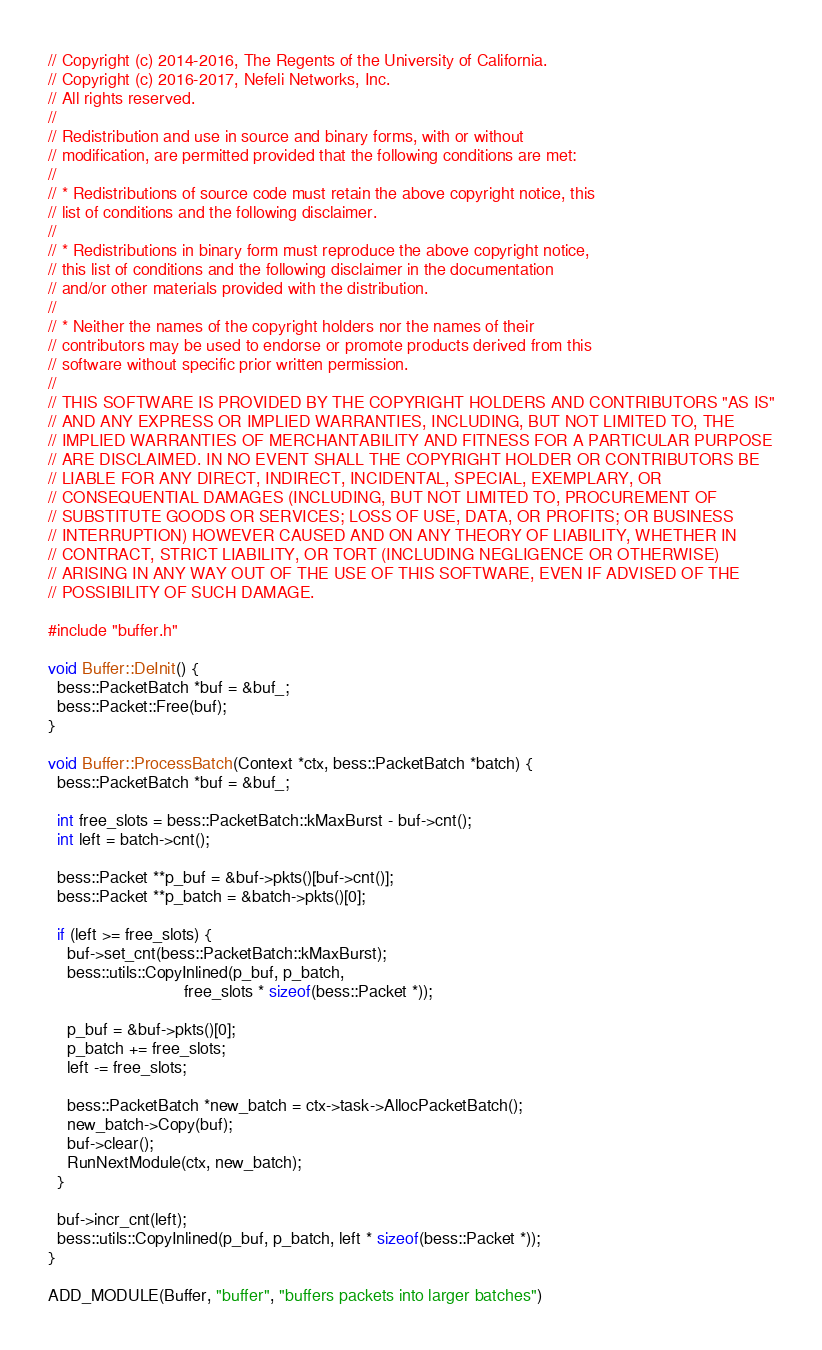Convert code to text. <code><loc_0><loc_0><loc_500><loc_500><_C++_>// Copyright (c) 2014-2016, The Regents of the University of California.
// Copyright (c) 2016-2017, Nefeli Networks, Inc.
// All rights reserved.
//
// Redistribution and use in source and binary forms, with or without
// modification, are permitted provided that the following conditions are met:
//
// * Redistributions of source code must retain the above copyright notice, this
// list of conditions and the following disclaimer.
//
// * Redistributions in binary form must reproduce the above copyright notice,
// this list of conditions and the following disclaimer in the documentation
// and/or other materials provided with the distribution.
//
// * Neither the names of the copyright holders nor the names of their
// contributors may be used to endorse or promote products derived from this
// software without specific prior written permission.
//
// THIS SOFTWARE IS PROVIDED BY THE COPYRIGHT HOLDERS AND CONTRIBUTORS "AS IS"
// AND ANY EXPRESS OR IMPLIED WARRANTIES, INCLUDING, BUT NOT LIMITED TO, THE
// IMPLIED WARRANTIES OF MERCHANTABILITY AND FITNESS FOR A PARTICULAR PURPOSE
// ARE DISCLAIMED. IN NO EVENT SHALL THE COPYRIGHT HOLDER OR CONTRIBUTORS BE
// LIABLE FOR ANY DIRECT, INDIRECT, INCIDENTAL, SPECIAL, EXEMPLARY, OR
// CONSEQUENTIAL DAMAGES (INCLUDING, BUT NOT LIMITED TO, PROCUREMENT OF
// SUBSTITUTE GOODS OR SERVICES; LOSS OF USE, DATA, OR PROFITS; OR BUSINESS
// INTERRUPTION) HOWEVER CAUSED AND ON ANY THEORY OF LIABILITY, WHETHER IN
// CONTRACT, STRICT LIABILITY, OR TORT (INCLUDING NEGLIGENCE OR OTHERWISE)
// ARISING IN ANY WAY OUT OF THE USE OF THIS SOFTWARE, EVEN IF ADVISED OF THE
// POSSIBILITY OF SUCH DAMAGE.

#include "buffer.h"

void Buffer::DeInit() {
  bess::PacketBatch *buf = &buf_;
  bess::Packet::Free(buf);
}

void Buffer::ProcessBatch(Context *ctx, bess::PacketBatch *batch) {
  bess::PacketBatch *buf = &buf_;

  int free_slots = bess::PacketBatch::kMaxBurst - buf->cnt();
  int left = batch->cnt();

  bess::Packet **p_buf = &buf->pkts()[buf->cnt()];
  bess::Packet **p_batch = &batch->pkts()[0];

  if (left >= free_slots) {
    buf->set_cnt(bess::PacketBatch::kMaxBurst);
    bess::utils::CopyInlined(p_buf, p_batch,
                             free_slots * sizeof(bess::Packet *));

    p_buf = &buf->pkts()[0];
    p_batch += free_slots;
    left -= free_slots;

    bess::PacketBatch *new_batch = ctx->task->AllocPacketBatch();
    new_batch->Copy(buf);
    buf->clear();
    RunNextModule(ctx, new_batch);
  }

  buf->incr_cnt(left);
  bess::utils::CopyInlined(p_buf, p_batch, left * sizeof(bess::Packet *));
}

ADD_MODULE(Buffer, "buffer", "buffers packets into larger batches")
</code> 